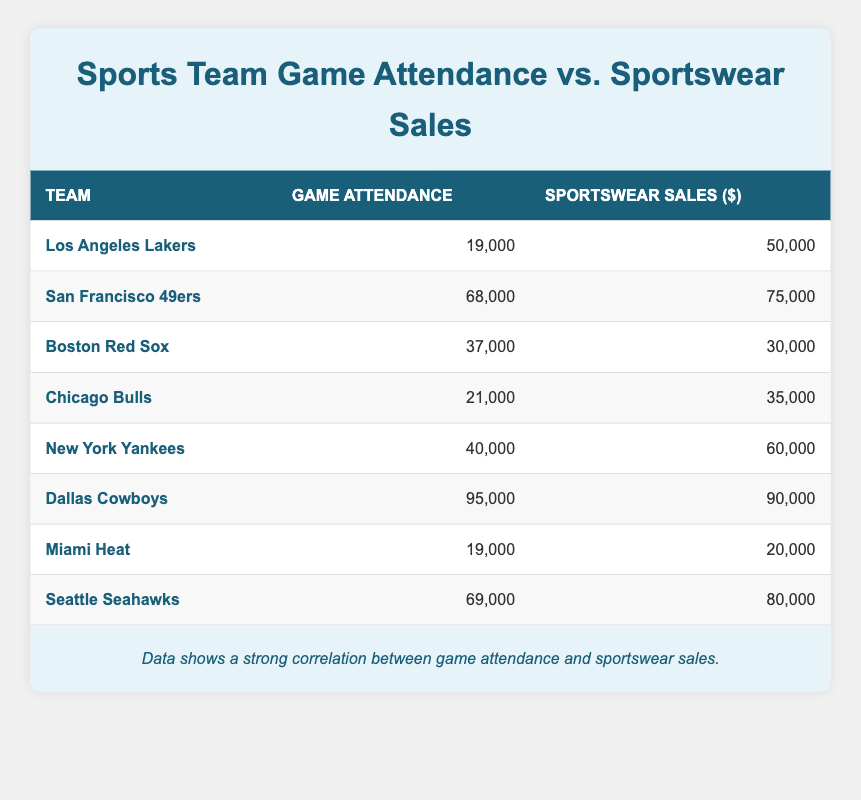What is the game attendance for the Dallas Cowboys? The table lists the Dallas Cowboys' game attendance in the row corresponding to the team, which shows a value of 95,000.
Answer: 95,000 Which team has the highest sportswear sales? By checking the sales column in the table, the Dallas Cowboys have the highest sales figure at 90,000, as reflected in their corresponding row.
Answer: Dallas Cowboys What is the total sportswear sales for teams with game attendance over 60,000? The teams with attendance over 60,000 are the San Francisco 49ers, Dallas Cowboys, and Seattle Seahawks. Their sales are 75,000, 90,000, and 80,000, respectively. Adding these gives 75,000 + 90,000 + 80,000 = 245,000.
Answer: 245,000 Is the sportswear sales of the Miami Heat greater than that of the New York Yankees? From the table, the sportswear sales for the Miami Heat is 20,000, while for the New York Yankees it is 60,000. Since 20,000 is less than 60,000, the statement is false.
Answer: No Which team has the lowest game attendance, and how much is their sportswear sales? By examining the game attendance column, the Miami Heat has the lowest attendance at 19,000. Their corresponding sportswear sales value is 20,000 from the same row.
Answer: Miami Heat, 20,000 What is the average game attendance for the teams listed in the table? To find the average, sum all attendance values: 19,000 + 68,000 + 37,000 + 21,000 + 40,000 + 95,000 + 19,000 + 69,000 = 368,000. There are 8 teams, so the average attendance is 368,000 / 8 = 46,000.
Answer: 46,000 Which team has the second highest game attendance? The teams are first sorted by attendance: Dallas Cowboys (95,000), Seattle Seahawks (69,000), and so on. The second highest attendance is for the Seattle Seahawks at 69,000.
Answer: Seattle Seahawks If every team in the table increased their sportswear sales by 10,000, what would be the new sales for the Boston Red Sox? To find the new sales, add 10,000 to the original sales of Boston Red Sox, which is 30,000. So the new sales would be 30,000 + 10,000 = 40,000.
Answer: 40,000 